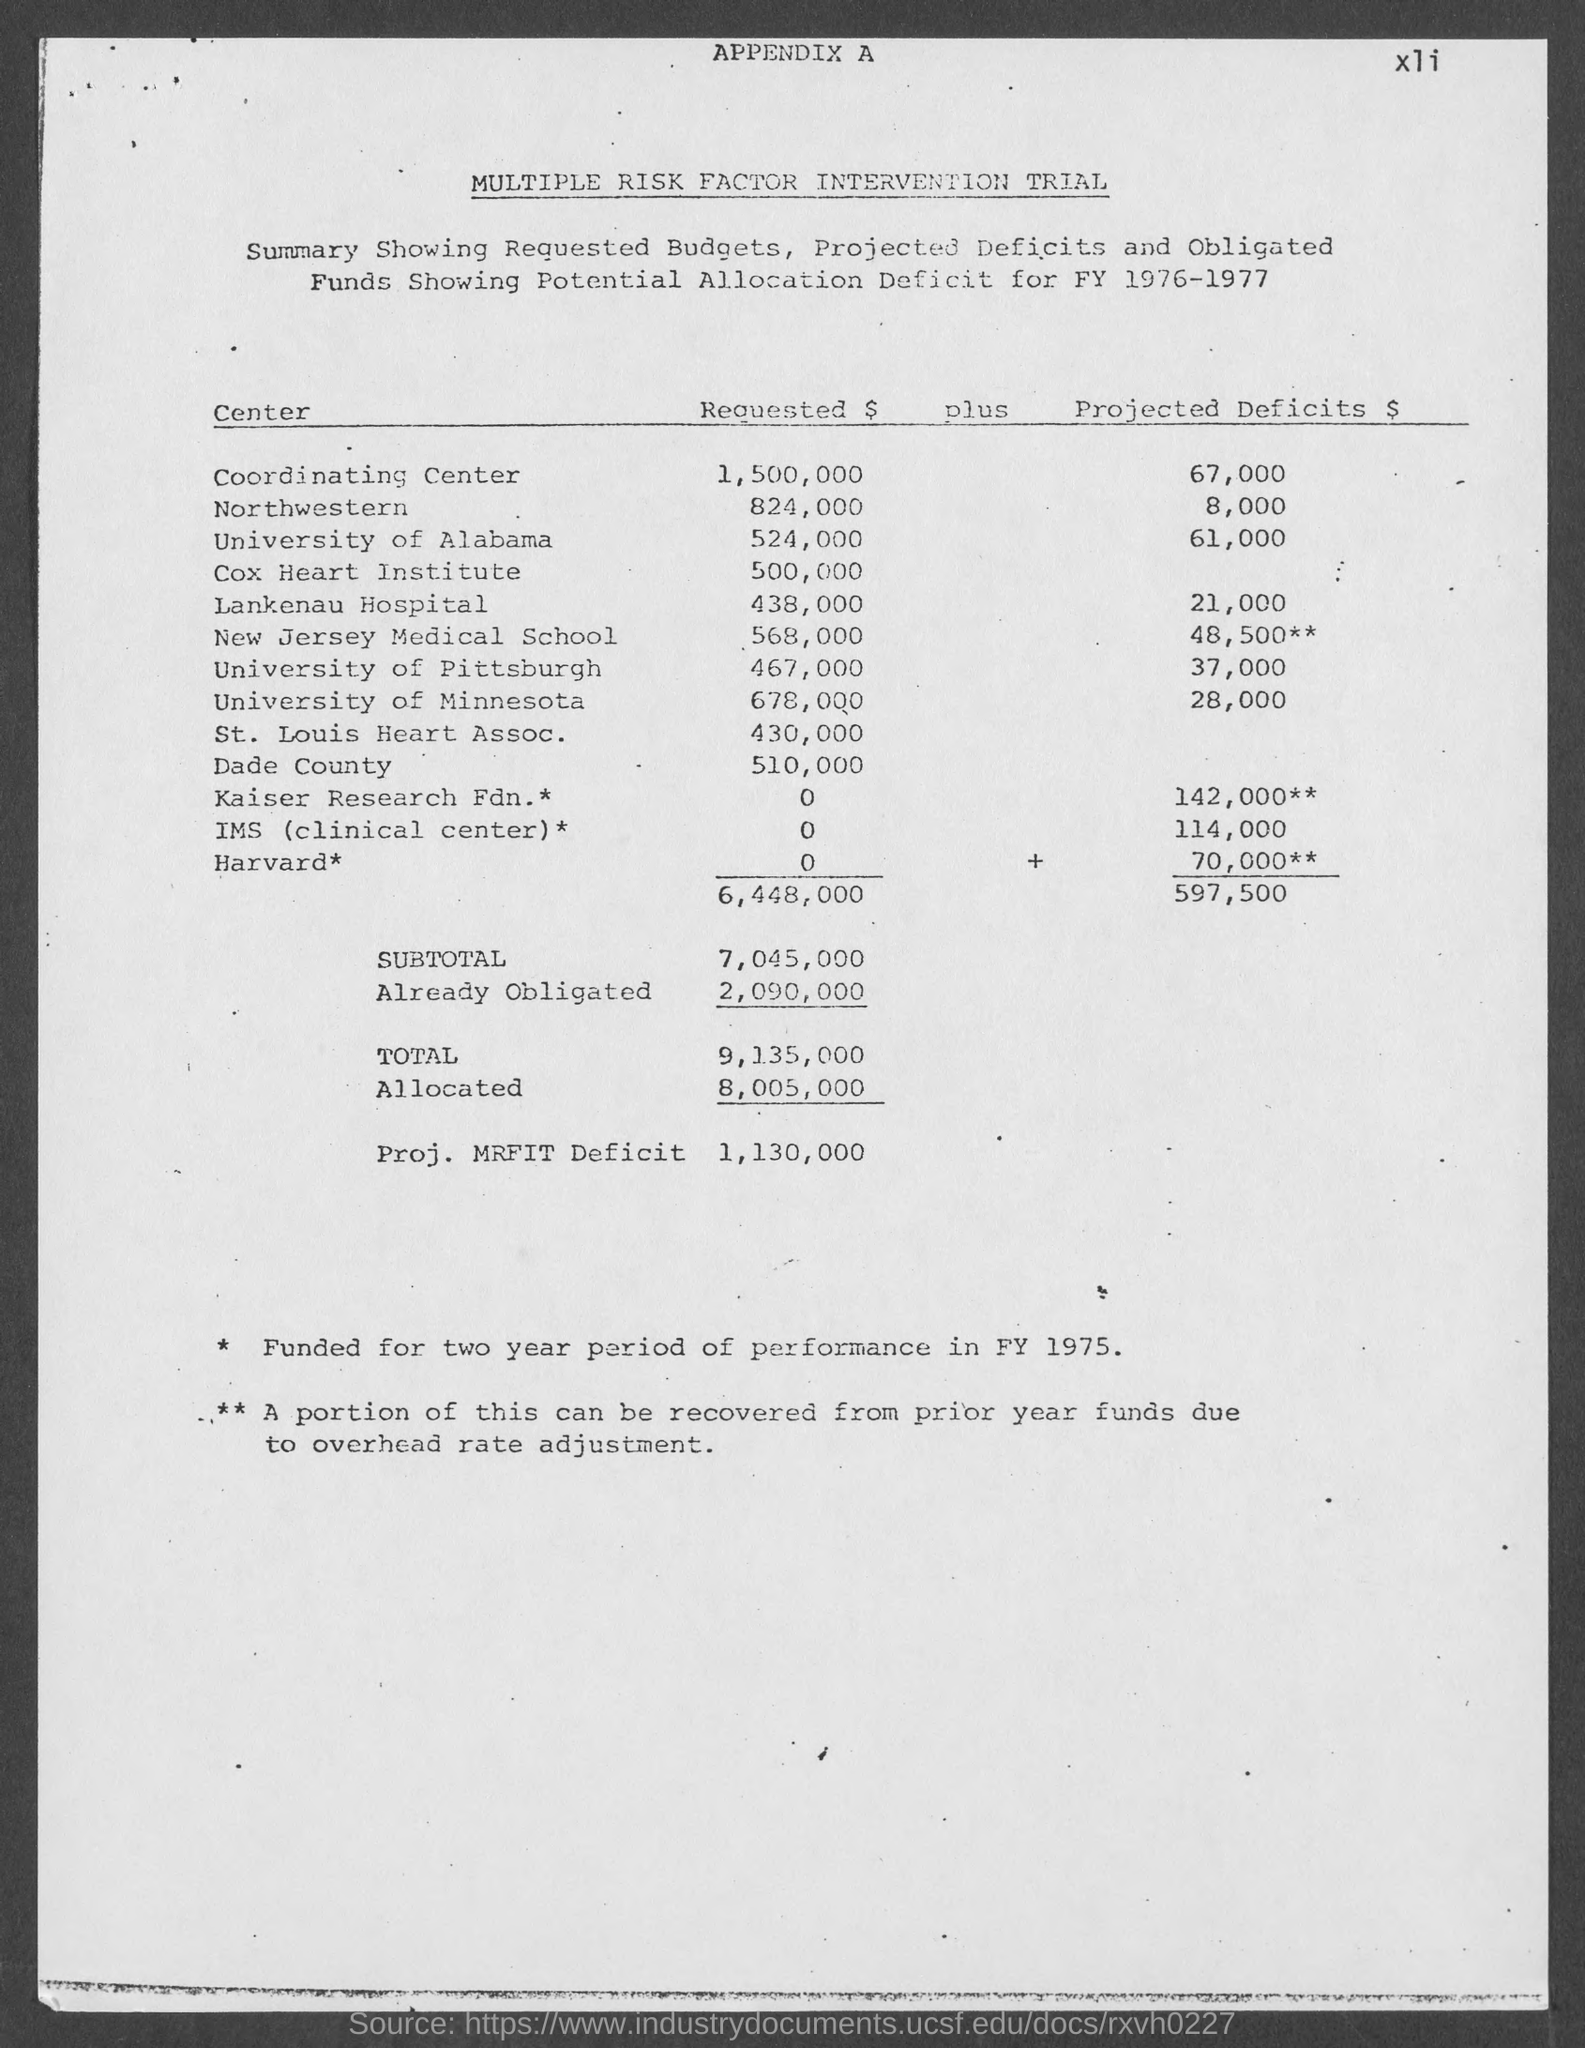Identify some key points in this picture. The projected deficits for Harvard are estimated to be approximately $70,000. According to the information provided, the projected deficit for the IMS (clinical center) is estimated to be $114,000. The projected deficits for the University of Minnesota are expected to reach $28,000. The projected deficit for the University of Alabama is expected to be approximately 61,000. The projected deficit for Northwestern Center is estimated to be approximately $8,000. 